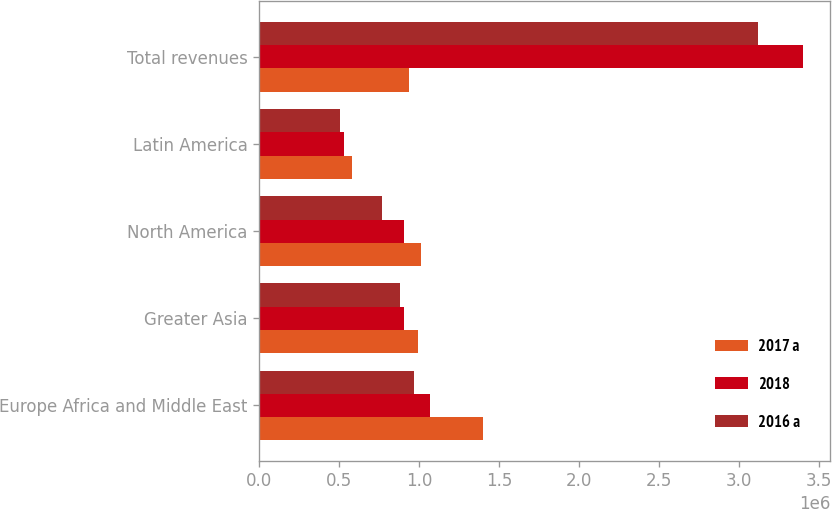<chart> <loc_0><loc_0><loc_500><loc_500><stacked_bar_chart><ecel><fcel>Europe Africa and Middle East<fcel>Greater Asia<fcel>North America<fcel>Latin America<fcel>Total revenues<nl><fcel>2017 a<fcel>1.39632e+06<fcel>991015<fcel>1.01013e+06<fcel>580083<fcel>934238<nl><fcel>2018<fcel>1.0656e+06<fcel>903546<fcel>901821<fcel>527756<fcel>3.39872e+06<nl><fcel>2016 a<fcel>964931<fcel>880040<fcel>769081<fcel>502298<fcel>3.11635e+06<nl></chart> 